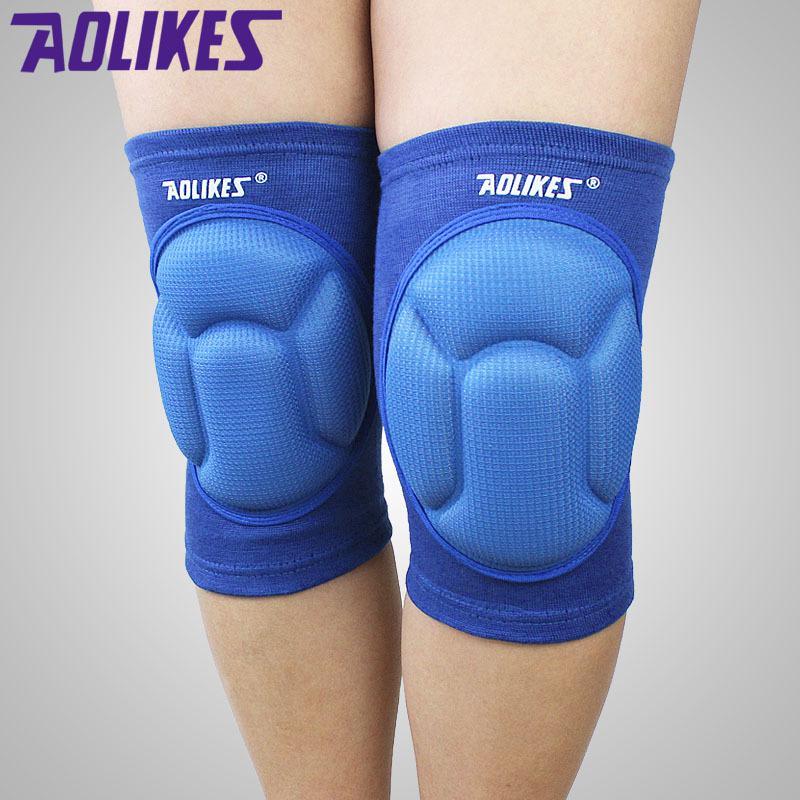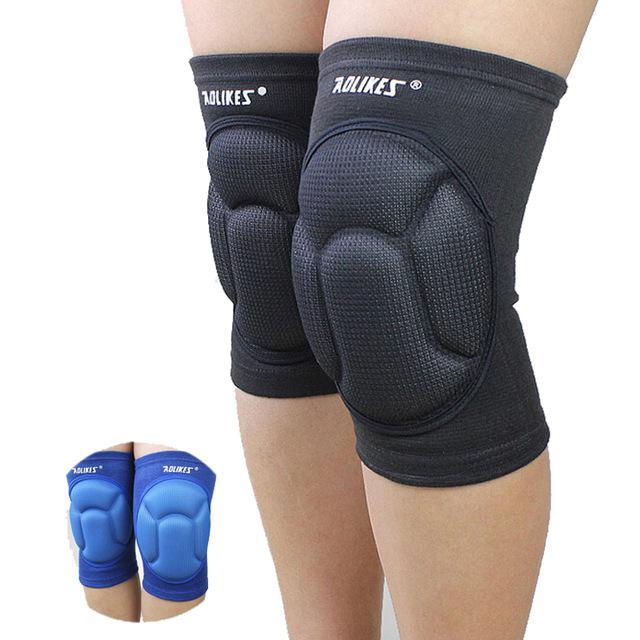The first image is the image on the left, the second image is the image on the right. Examine the images to the left and right. Is the description "There is a single blue kneepad in one image and two black kneepads in the other image." accurate? Answer yes or no. No. The first image is the image on the left, the second image is the image on the right. Given the left and right images, does the statement "Two black kneepads are modeled in one image, but a second image shows only one kneepad of a different color." hold true? Answer yes or no. No. 